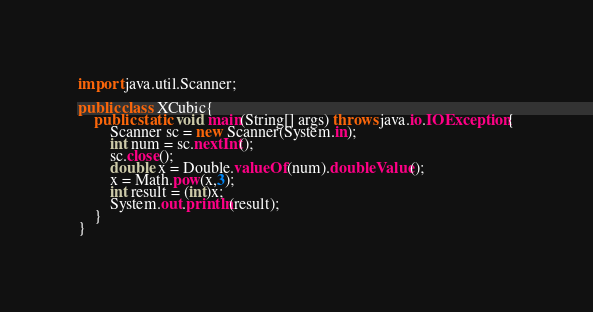Convert code to text. <code><loc_0><loc_0><loc_500><loc_500><_Java_>import java.util.Scanner;

public class XCubic{
	public static void main(String[] args) throws java.io.IOException{
		Scanner sc = new Scanner(System.in);
		int num = sc.nextInt();
		sc.close();
		double x = Double.valueOf(num).doubleValue();
		x = Math.pow(x,3);
		int result = (int)x;
		System.out.println(result);
	}
}</code> 